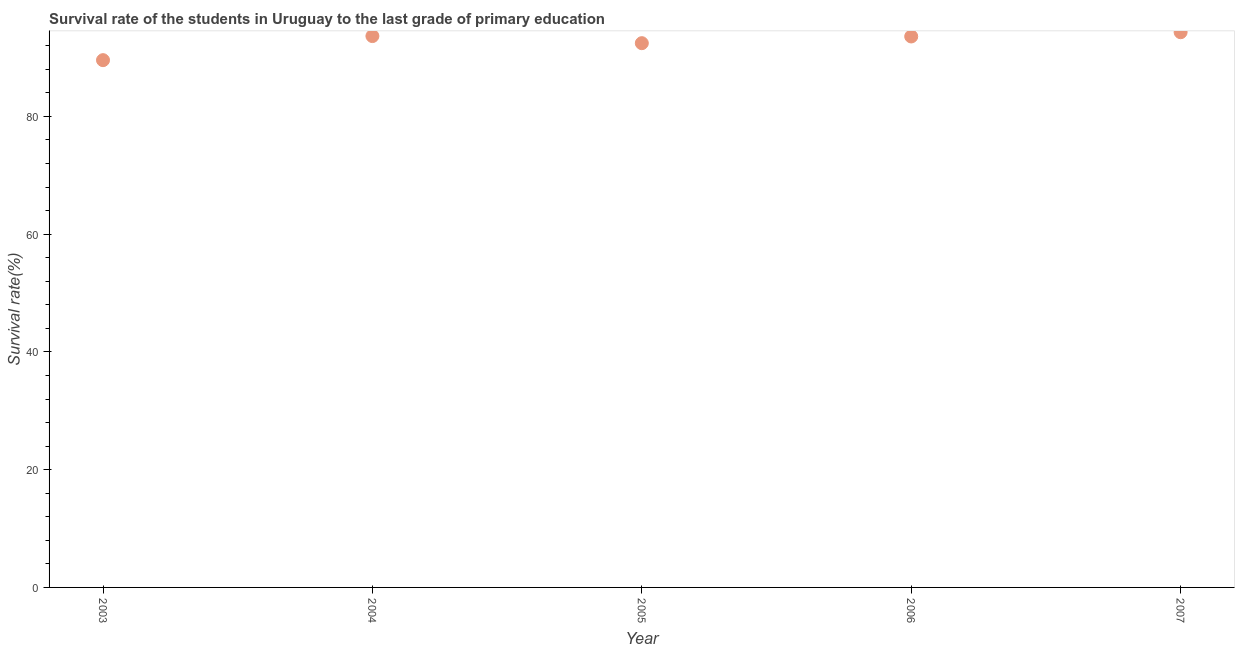What is the survival rate in primary education in 2005?
Offer a terse response. 92.45. Across all years, what is the maximum survival rate in primary education?
Provide a short and direct response. 94.31. Across all years, what is the minimum survival rate in primary education?
Make the answer very short. 89.56. In which year was the survival rate in primary education maximum?
Provide a succinct answer. 2007. What is the sum of the survival rate in primary education?
Keep it short and to the point. 463.55. What is the difference between the survival rate in primary education in 2004 and 2006?
Your answer should be very brief. 0.07. What is the average survival rate in primary education per year?
Provide a succinct answer. 92.71. What is the median survival rate in primary education?
Keep it short and to the point. 93.58. In how many years, is the survival rate in primary education greater than 88 %?
Provide a short and direct response. 5. What is the ratio of the survival rate in primary education in 2003 to that in 2007?
Your answer should be compact. 0.95. Is the survival rate in primary education in 2003 less than that in 2005?
Offer a very short reply. Yes. Is the difference between the survival rate in primary education in 2005 and 2007 greater than the difference between any two years?
Give a very brief answer. No. What is the difference between the highest and the second highest survival rate in primary education?
Provide a short and direct response. 0.66. What is the difference between the highest and the lowest survival rate in primary education?
Your answer should be very brief. 4.75. How many dotlines are there?
Keep it short and to the point. 1. How many years are there in the graph?
Give a very brief answer. 5. What is the difference between two consecutive major ticks on the Y-axis?
Your response must be concise. 20. Does the graph contain grids?
Offer a very short reply. No. What is the title of the graph?
Offer a very short reply. Survival rate of the students in Uruguay to the last grade of primary education. What is the label or title of the Y-axis?
Your answer should be compact. Survival rate(%). What is the Survival rate(%) in 2003?
Give a very brief answer. 89.56. What is the Survival rate(%) in 2004?
Your answer should be compact. 93.65. What is the Survival rate(%) in 2005?
Your answer should be very brief. 92.45. What is the Survival rate(%) in 2006?
Your answer should be very brief. 93.58. What is the Survival rate(%) in 2007?
Give a very brief answer. 94.31. What is the difference between the Survival rate(%) in 2003 and 2004?
Provide a succinct answer. -4.09. What is the difference between the Survival rate(%) in 2003 and 2005?
Make the answer very short. -2.88. What is the difference between the Survival rate(%) in 2003 and 2006?
Your response must be concise. -4.02. What is the difference between the Survival rate(%) in 2003 and 2007?
Give a very brief answer. -4.75. What is the difference between the Survival rate(%) in 2004 and 2005?
Give a very brief answer. 1.21. What is the difference between the Survival rate(%) in 2004 and 2006?
Your answer should be very brief. 0.07. What is the difference between the Survival rate(%) in 2004 and 2007?
Give a very brief answer. -0.66. What is the difference between the Survival rate(%) in 2005 and 2006?
Give a very brief answer. -1.14. What is the difference between the Survival rate(%) in 2005 and 2007?
Keep it short and to the point. -1.86. What is the difference between the Survival rate(%) in 2006 and 2007?
Your response must be concise. -0.72. What is the ratio of the Survival rate(%) in 2003 to that in 2004?
Your response must be concise. 0.96. What is the ratio of the Survival rate(%) in 2003 to that in 2005?
Your answer should be compact. 0.97. What is the ratio of the Survival rate(%) in 2004 to that in 2005?
Provide a short and direct response. 1.01. What is the ratio of the Survival rate(%) in 2005 to that in 2007?
Offer a very short reply. 0.98. 